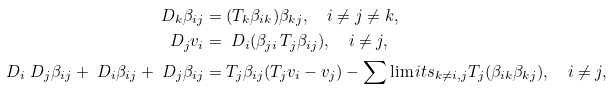<formula> <loc_0><loc_0><loc_500><loc_500>\ D _ { k } \beta _ { i j } & = ( T _ { k } \beta _ { i k } ) \beta _ { k j } , \quad i \ne j \ne k , \\ \ D _ { j } v _ { i } & = \ D _ { i } ( \beta _ { j i } \, T _ { j } \beta _ { i j } ) , \quad i \ne j , \\ \ D _ { i } \ D _ { j } \beta _ { i j } + \ D _ { i } \beta _ { i j } + \ D _ { j } \beta _ { i j } & = T _ { j } \beta _ { i j } ( T _ { j } v _ { i } - v _ { j } ) - \sum \lim i t s _ { k \ne i , j } T _ { j } ( \beta _ { i k } \beta _ { k j } ) , \quad i \ne j ,</formula> 